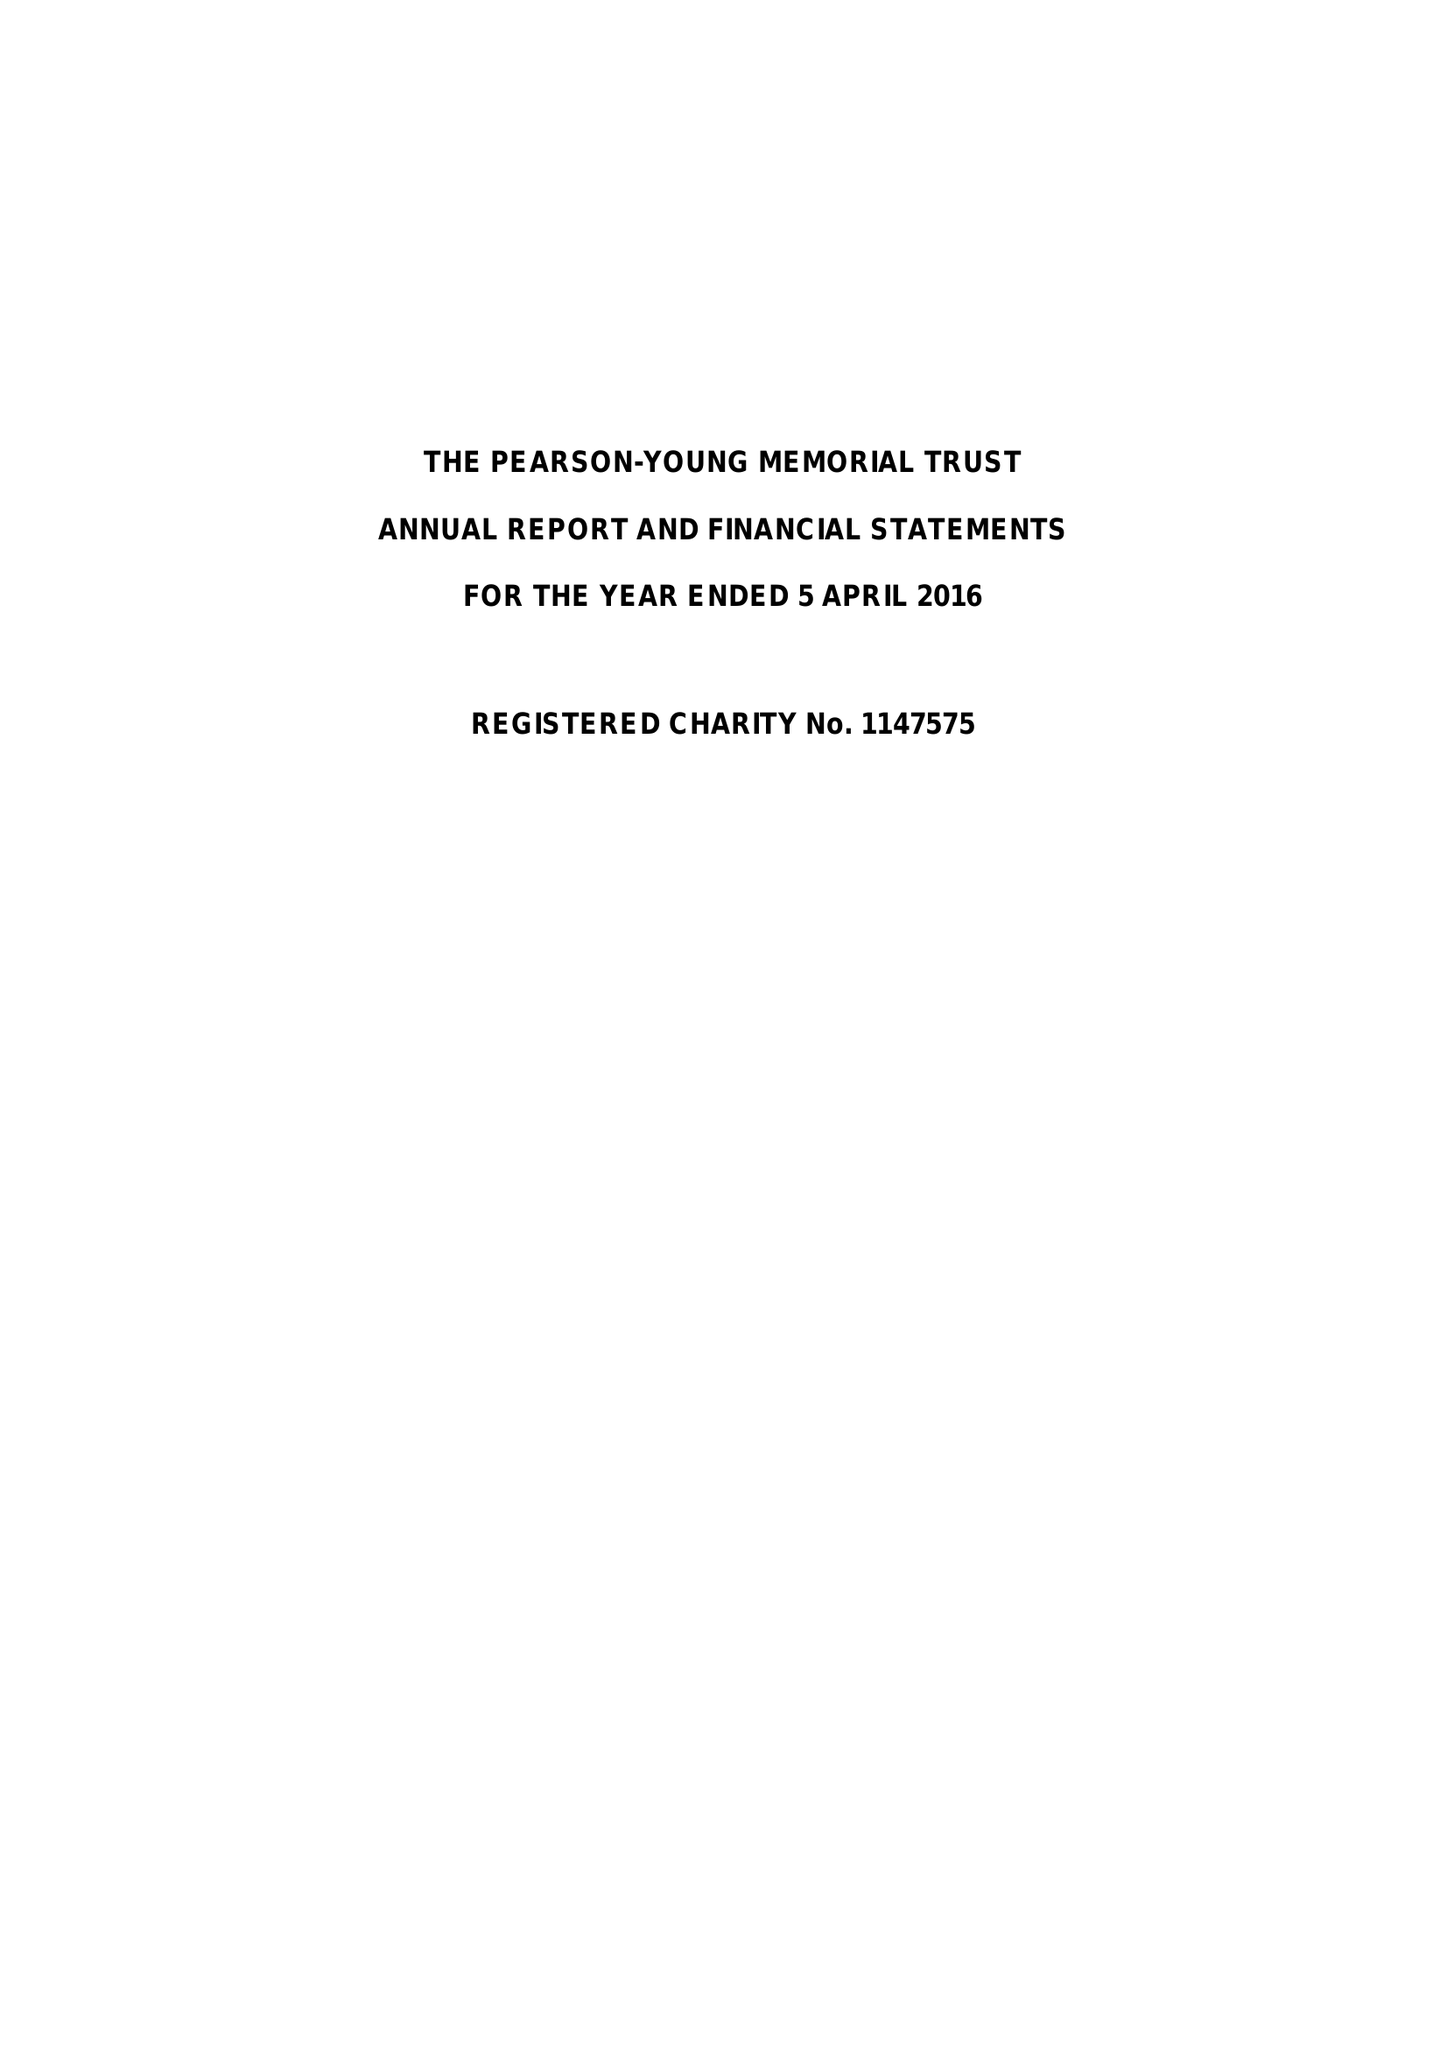What is the value for the spending_annually_in_british_pounds?
Answer the question using a single word or phrase. 43188.10 